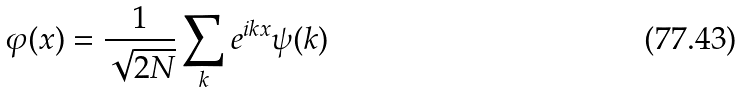<formula> <loc_0><loc_0><loc_500><loc_500>\varphi ( x ) = \frac { 1 } { \sqrt { 2 N } } \sum _ { k } e ^ { i k x } \psi ( k )</formula> 